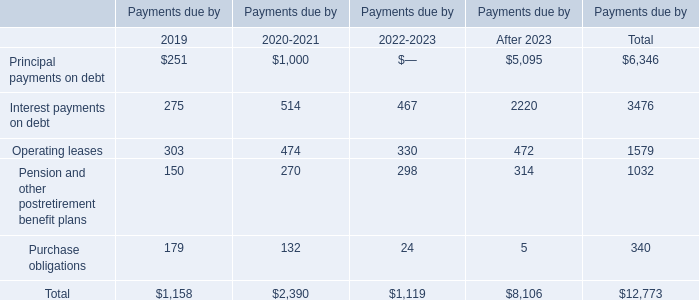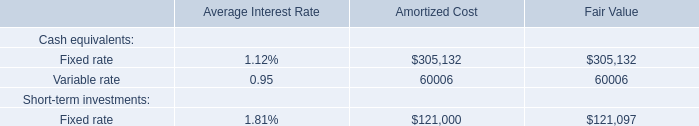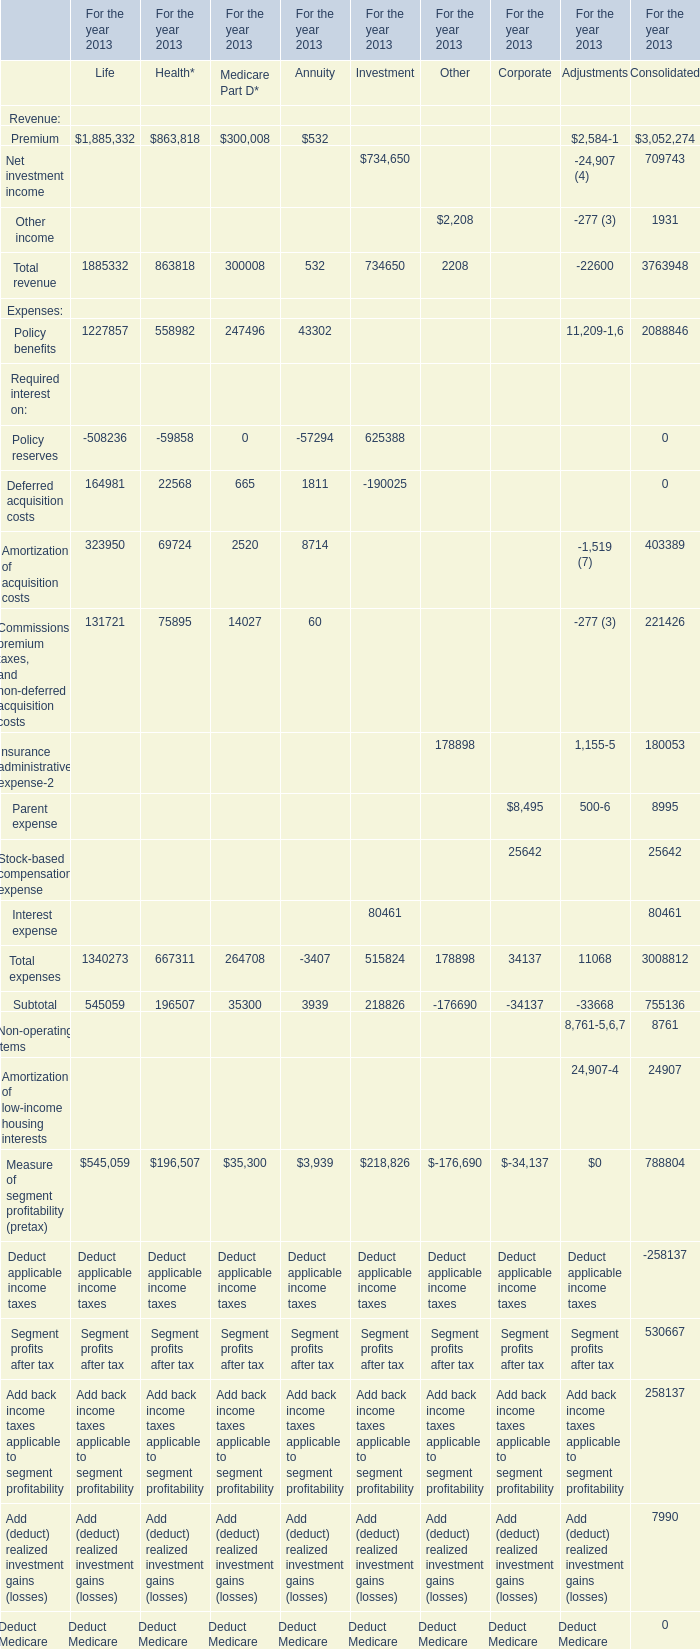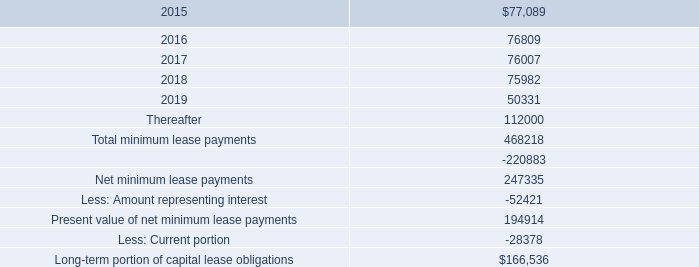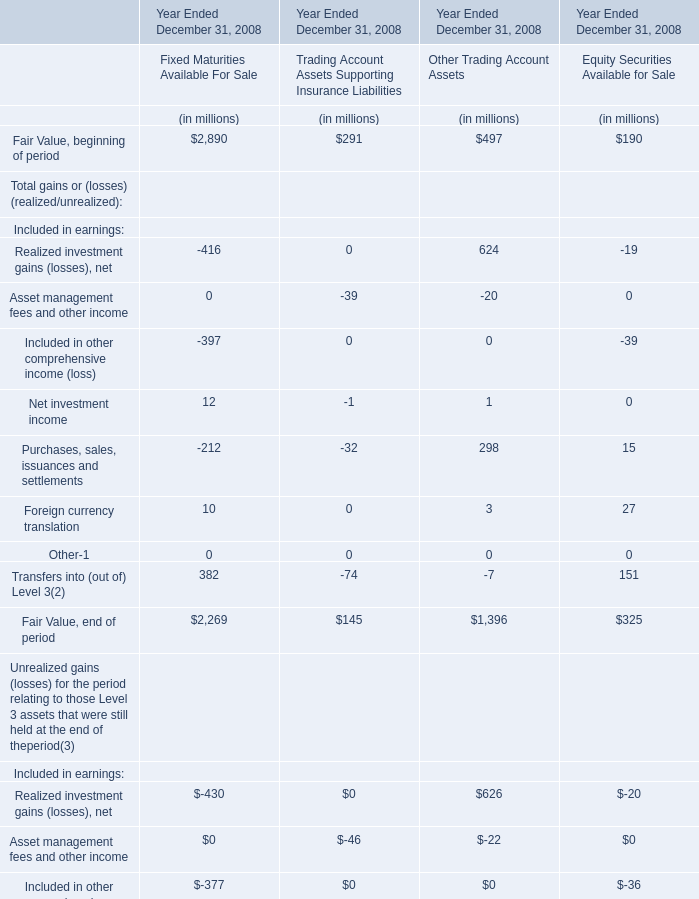As As the chart 1 shows,what is the sum of Fair Value, end of period for Trading Account Assets Supporting Insurance Liabilities for Year Ended December 31, 2008? (in million) 
Answer: 145. 